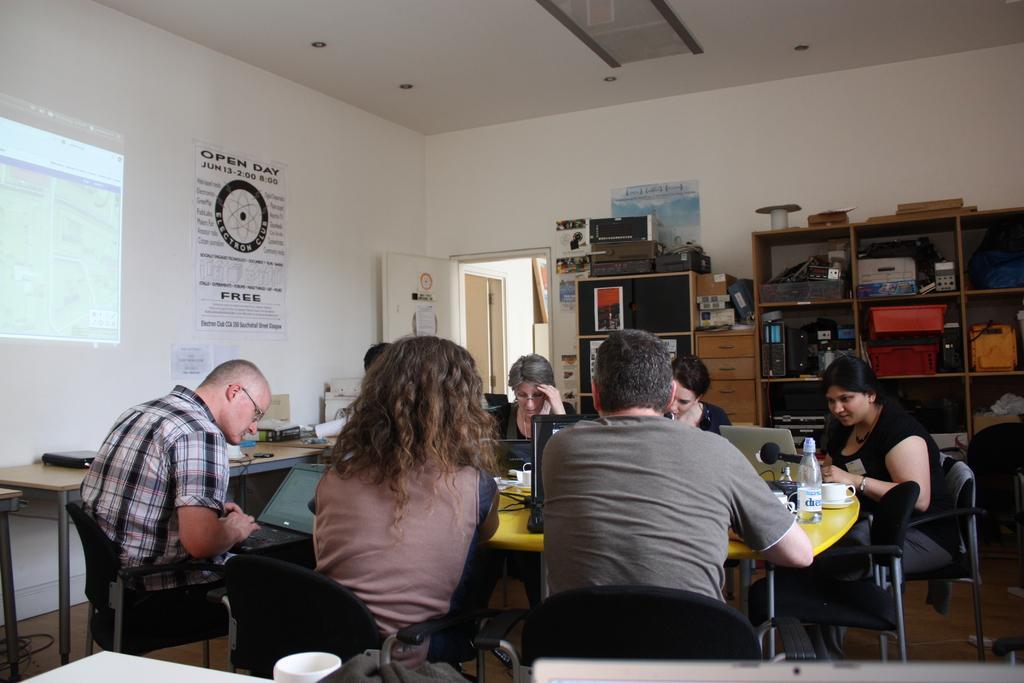How would you summarize this image in a sentence or two? There are group of people sitting in front of a yellow table which has laptops on it and there is a projected image in the left corner and the wall is white in color. 